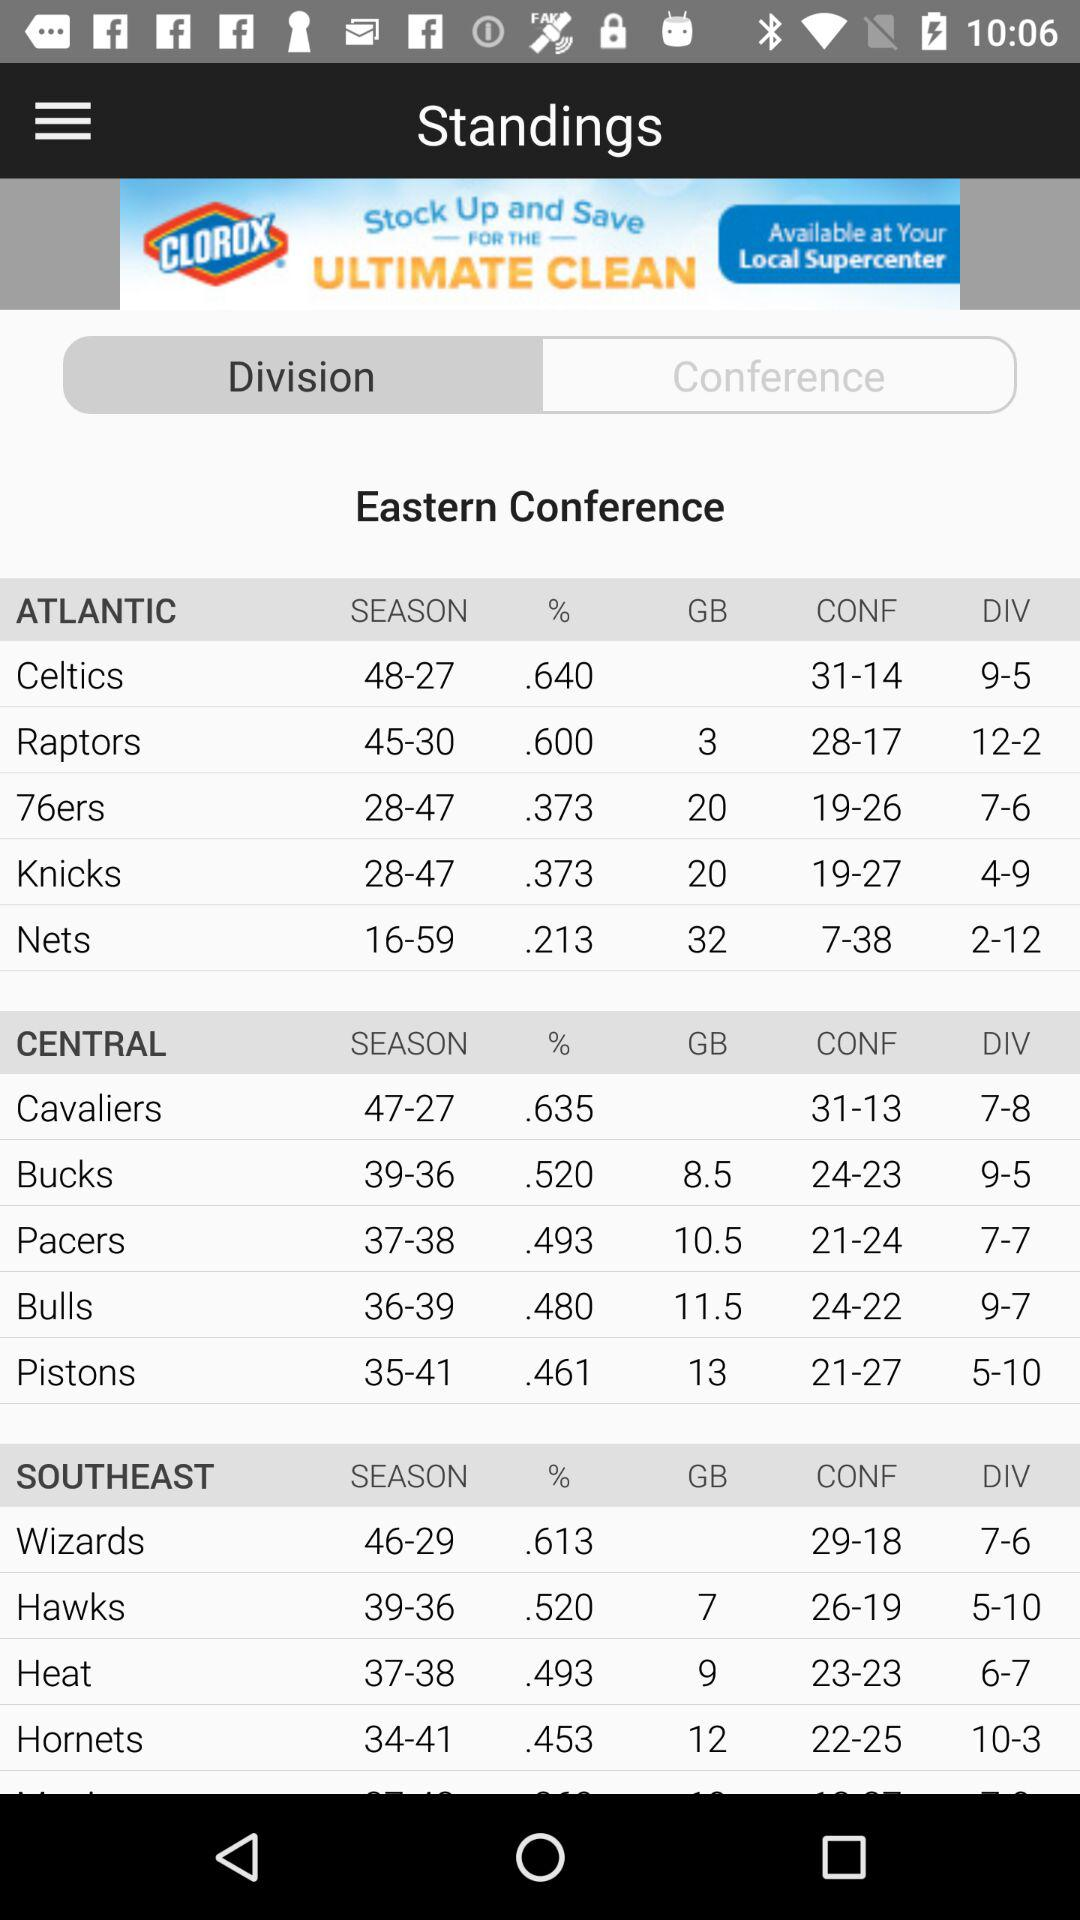What is the division of "Raptors"? The division is 12-2. 